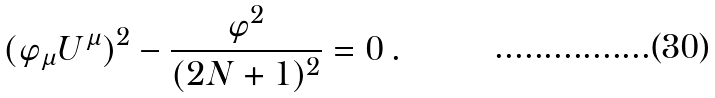Convert formula to latex. <formula><loc_0><loc_0><loc_500><loc_500>( \varphi _ { \mu } U ^ { \mu } ) ^ { 2 } - \frac { \varphi ^ { 2 } } { ( 2 N + 1 ) ^ { 2 } } = 0 \, .</formula> 